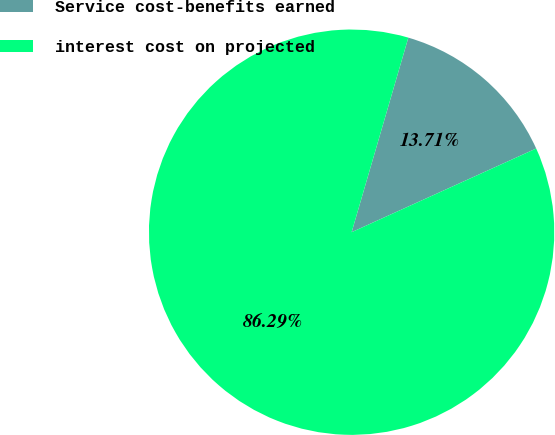<chart> <loc_0><loc_0><loc_500><loc_500><pie_chart><fcel>Service cost-benefits earned<fcel>interest cost on projected<nl><fcel>13.71%<fcel>86.29%<nl></chart> 